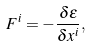<formula> <loc_0><loc_0><loc_500><loc_500>F ^ { i } = - \frac { \delta \varepsilon } { \delta x ^ { i } } ,</formula> 